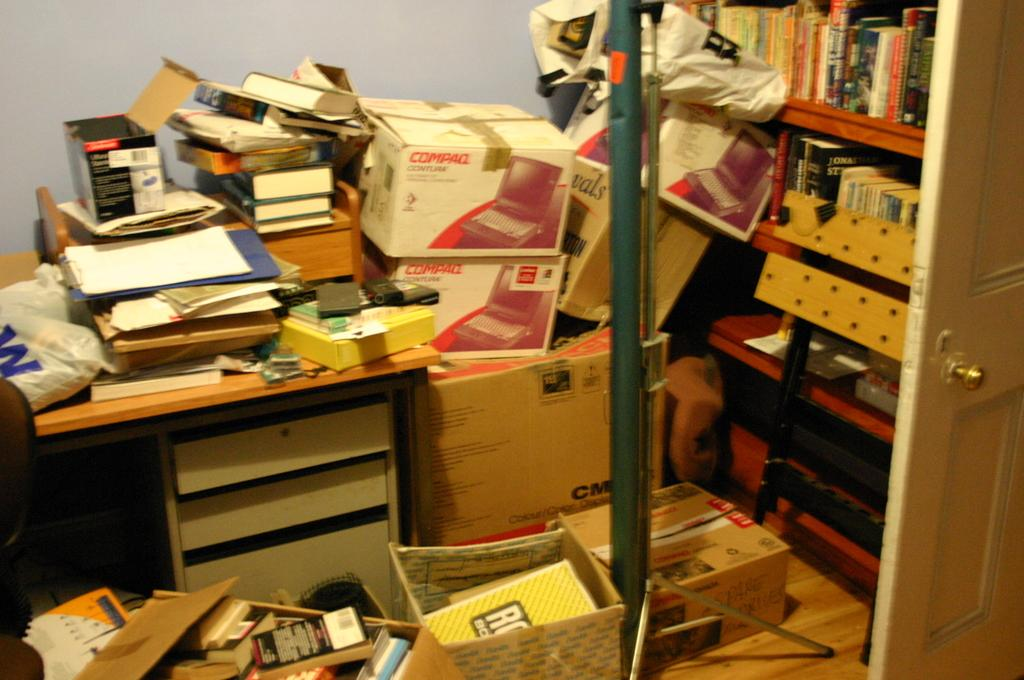Provide a one-sentence caption for the provided image. A messy room has two boxes that say Compaq. 